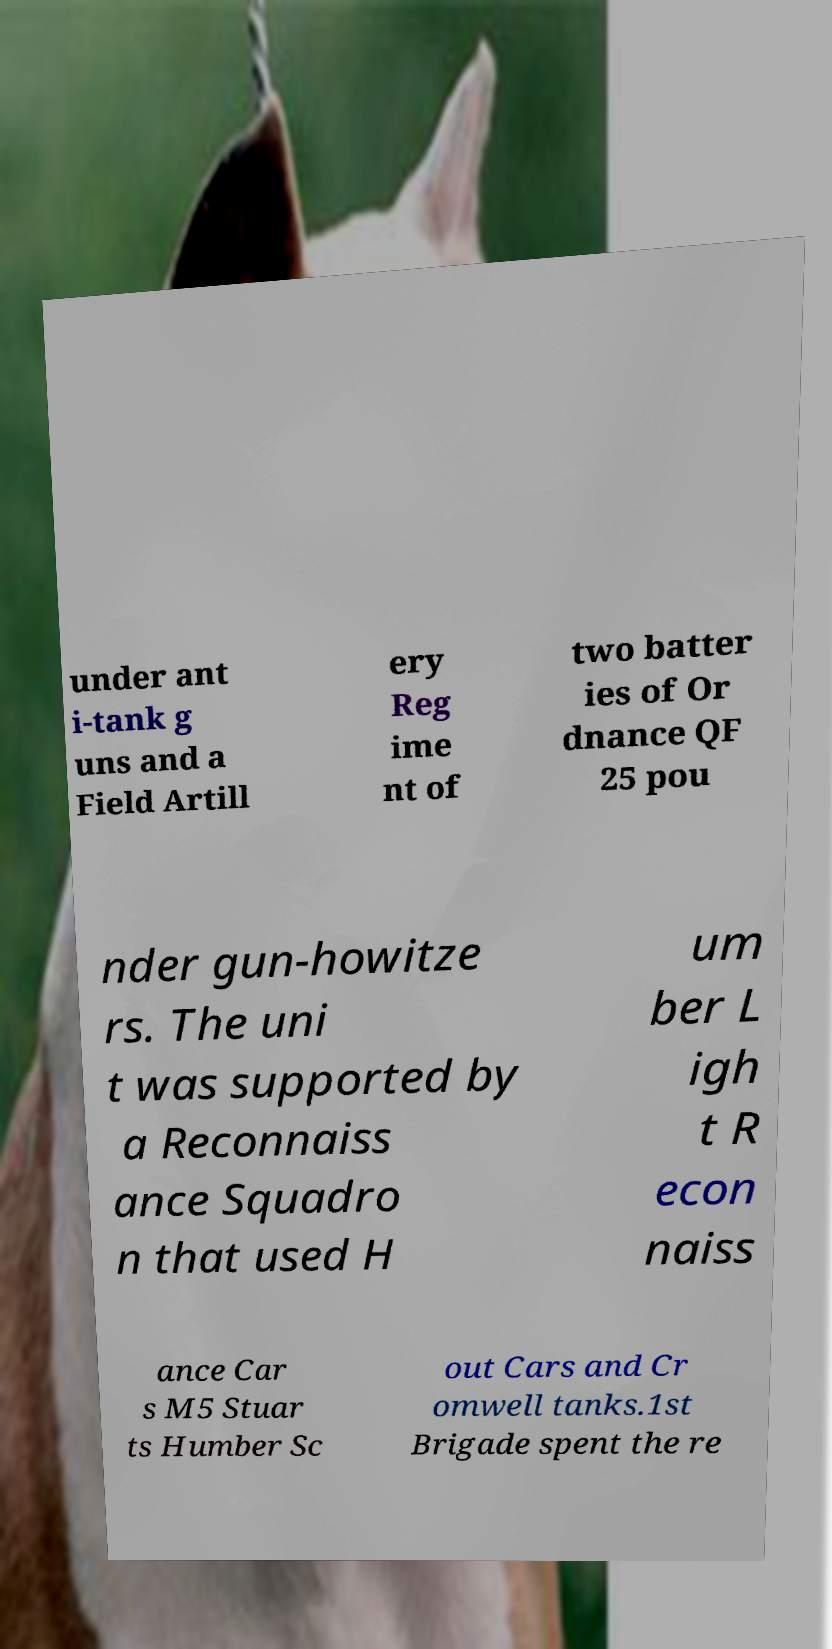Can you accurately transcribe the text from the provided image for me? under ant i-tank g uns and a Field Artill ery Reg ime nt of two batter ies of Or dnance QF 25 pou nder gun-howitze rs. The uni t was supported by a Reconnaiss ance Squadro n that used H um ber L igh t R econ naiss ance Car s M5 Stuar ts Humber Sc out Cars and Cr omwell tanks.1st Brigade spent the re 